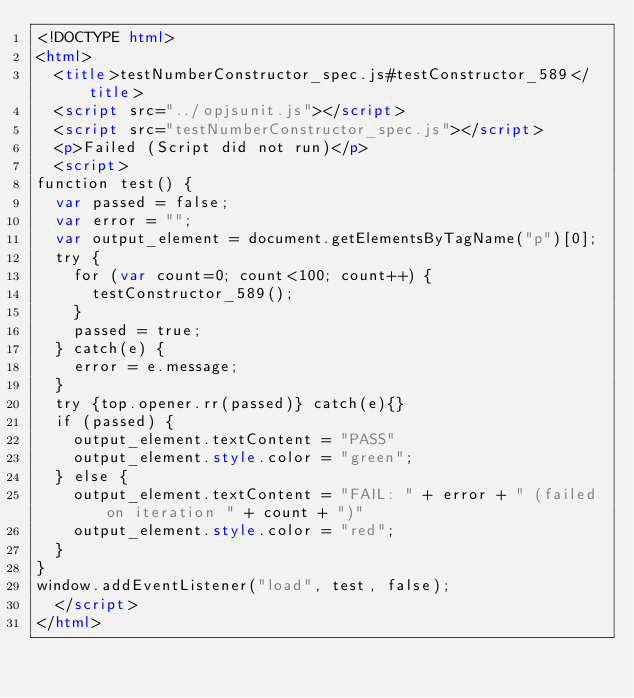Convert code to text. <code><loc_0><loc_0><loc_500><loc_500><_HTML_><!DOCTYPE html>
<html>
  <title>testNumberConstructor_spec.js#testConstructor_589</title>
  <script src="../opjsunit.js"></script>
  <script src="testNumberConstructor_spec.js"></script>
  <p>Failed (Script did not run)</p>
  <script>
function test() {
  var passed = false;
  var error = "";
  var output_element = document.getElementsByTagName("p")[0];
  try {
    for (var count=0; count<100; count++) {
      testConstructor_589();
    }
    passed = true;
  } catch(e) {
    error = e.message;
  }
  try {top.opener.rr(passed)} catch(e){}
  if (passed) {
    output_element.textContent = "PASS"
    output_element.style.color = "green";
  } else {
    output_element.textContent = "FAIL: " + error + " (failed on iteration " + count + ")"
    output_element.style.color = "red";
  }
}
window.addEventListener("load", test, false);
  </script>
</html></code> 